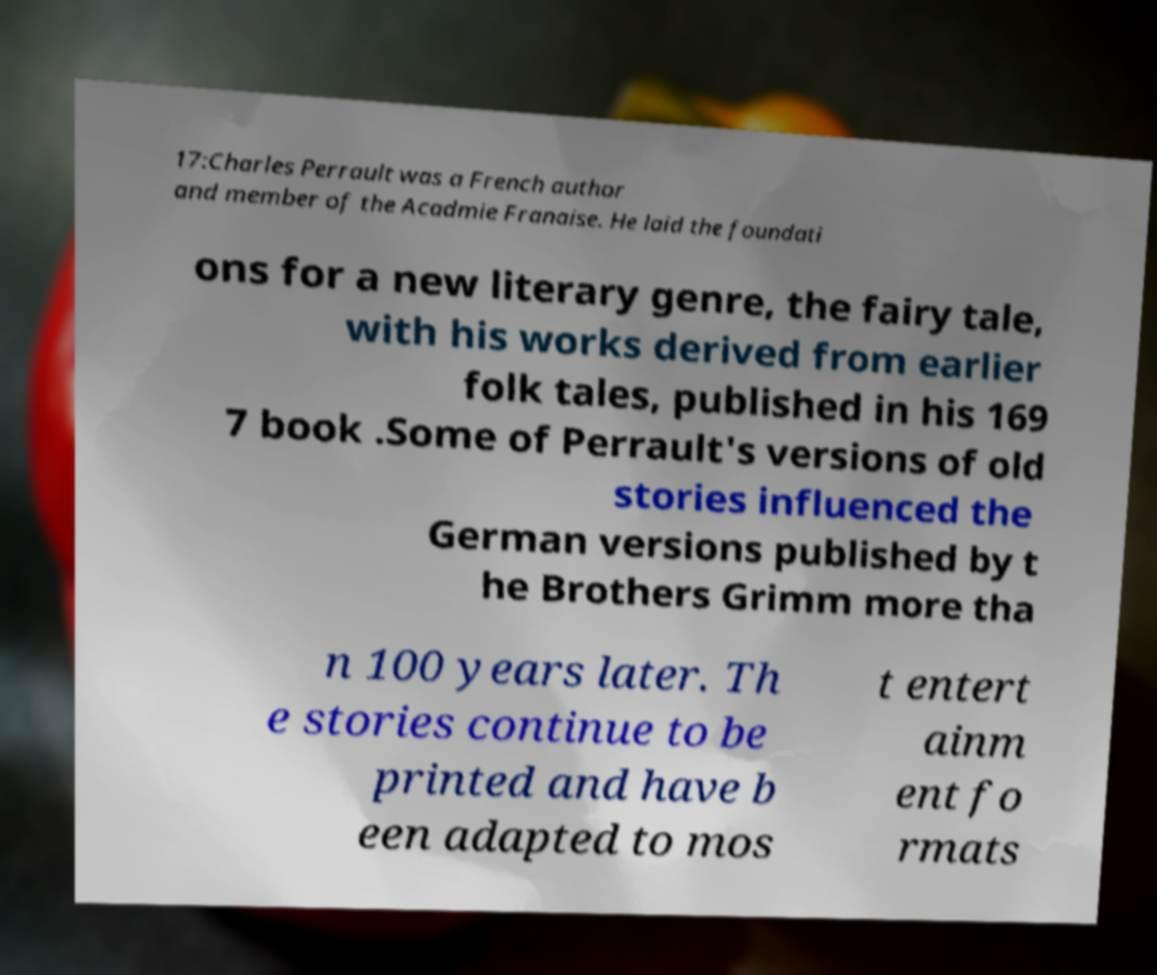Please read and relay the text visible in this image. What does it say? 17:Charles Perrault was a French author and member of the Acadmie Franaise. He laid the foundati ons for a new literary genre, the fairy tale, with his works derived from earlier folk tales, published in his 169 7 book .Some of Perrault's versions of old stories influenced the German versions published by t he Brothers Grimm more tha n 100 years later. Th e stories continue to be printed and have b een adapted to mos t entert ainm ent fo rmats 